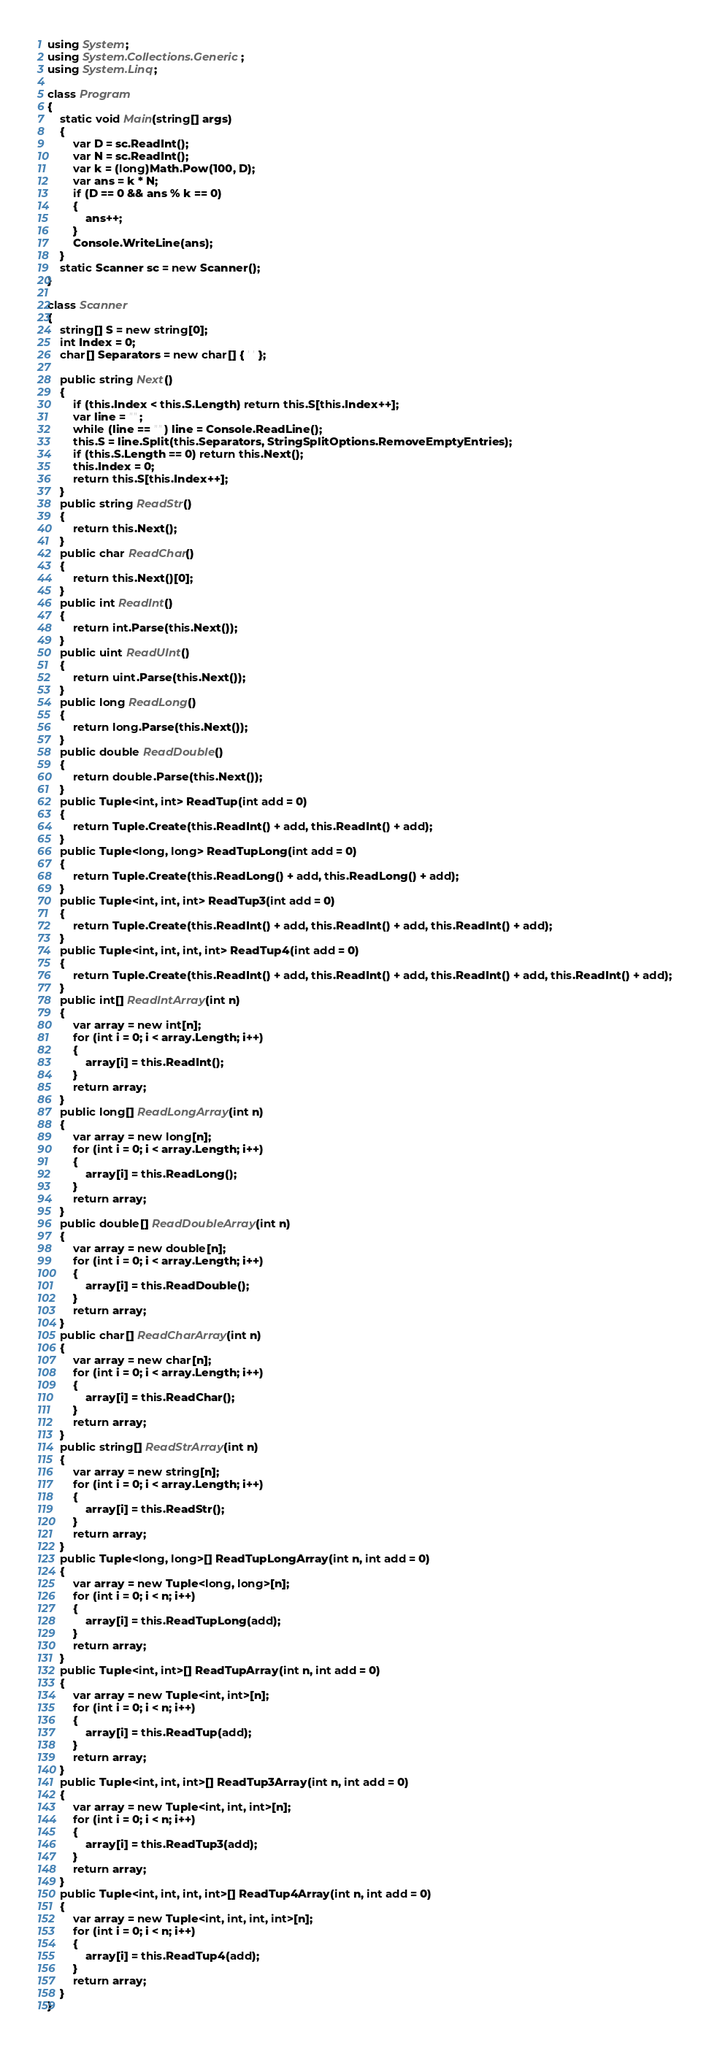Convert code to text. <code><loc_0><loc_0><loc_500><loc_500><_C#_>using System;
using System.Collections.Generic;
using System.Linq;

class Program
{
    static void Main(string[] args)
    {
        var D = sc.ReadInt();
        var N = sc.ReadInt();
        var k = (long)Math.Pow(100, D);
        var ans = k * N;
        if (D == 0 && ans % k == 0)
        {
            ans++;
        }
        Console.WriteLine(ans);
    }
    static Scanner sc = new Scanner();
}

class Scanner
{
    string[] S = new string[0];
    int Index = 0;
    char[] Separators = new char[] { ' ' };

    public string Next()
    {
        if (this.Index < this.S.Length) return this.S[this.Index++];
        var line = "";
        while (line == "") line = Console.ReadLine();
        this.S = line.Split(this.Separators, StringSplitOptions.RemoveEmptyEntries);
        if (this.S.Length == 0) return this.Next();
        this.Index = 0;
        return this.S[this.Index++];
    }
    public string ReadStr()
    {
        return this.Next();
    }
    public char ReadChar()
    {
        return this.Next()[0];
    }
    public int ReadInt()
    {
        return int.Parse(this.Next());
    }
    public uint ReadUInt()
    {
        return uint.Parse(this.Next());
    }
    public long ReadLong()
    {
        return long.Parse(this.Next());
    }
    public double ReadDouble()
    {
        return double.Parse(this.Next());
    }
    public Tuple<int, int> ReadTup(int add = 0)
    {
        return Tuple.Create(this.ReadInt() + add, this.ReadInt() + add);
    }
    public Tuple<long, long> ReadTupLong(int add = 0)
    {
        return Tuple.Create(this.ReadLong() + add, this.ReadLong() + add);
    }
    public Tuple<int, int, int> ReadTup3(int add = 0)
    {
        return Tuple.Create(this.ReadInt() + add, this.ReadInt() + add, this.ReadInt() + add);
    }
    public Tuple<int, int, int, int> ReadTup4(int add = 0)
    {
        return Tuple.Create(this.ReadInt() + add, this.ReadInt() + add, this.ReadInt() + add, this.ReadInt() + add);
    }
    public int[] ReadIntArray(int n)
    {
        var array = new int[n];
        for (int i = 0; i < array.Length; i++)
        {
            array[i] = this.ReadInt();
        }
        return array;
    }
    public long[] ReadLongArray(int n)
    {
        var array = new long[n];
        for (int i = 0; i < array.Length; i++)
        {
            array[i] = this.ReadLong();
        }
        return array;
    }
    public double[] ReadDoubleArray(int n)
    {
        var array = new double[n];
        for (int i = 0; i < array.Length; i++)
        {
            array[i] = this.ReadDouble();
        }
        return array;
    }
    public char[] ReadCharArray(int n)
    {
        var array = new char[n];
        for (int i = 0; i < array.Length; i++)
        {
            array[i] = this.ReadChar();
        }
        return array;
    }
    public string[] ReadStrArray(int n)
    {
        var array = new string[n];
        for (int i = 0; i < array.Length; i++)
        {
            array[i] = this.ReadStr();
        }
        return array;
    }
    public Tuple<long, long>[] ReadTupLongArray(int n, int add = 0)
    {
        var array = new Tuple<long, long>[n];
        for (int i = 0; i < n; i++)
        {
            array[i] = this.ReadTupLong(add);
        }
        return array;
    }
    public Tuple<int, int>[] ReadTupArray(int n, int add = 0)
    {
        var array = new Tuple<int, int>[n];
        for (int i = 0; i < n; i++)
        {
            array[i] = this.ReadTup(add);
        }
        return array;
    }
    public Tuple<int, int, int>[] ReadTup3Array(int n, int add = 0)
    {
        var array = new Tuple<int, int, int>[n];
        for (int i = 0; i < n; i++)
        {
            array[i] = this.ReadTup3(add);
        }
        return array;
    }
    public Tuple<int, int, int, int>[] ReadTup4Array(int n, int add = 0)
    {
        var array = new Tuple<int, int, int, int>[n];
        for (int i = 0; i < n; i++)
        {
            array[i] = this.ReadTup4(add);
        }
        return array;
    }
}
</code> 